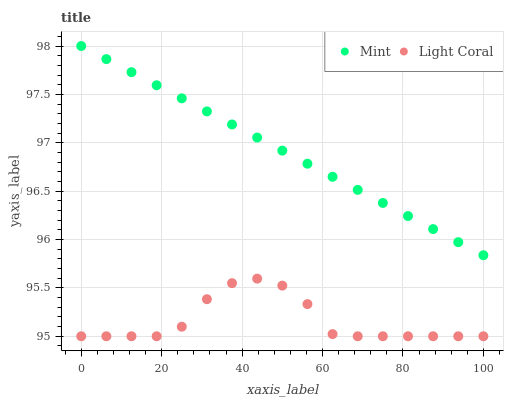Does Light Coral have the minimum area under the curve?
Answer yes or no. Yes. Does Mint have the maximum area under the curve?
Answer yes or no. Yes. Does Mint have the minimum area under the curve?
Answer yes or no. No. Is Mint the smoothest?
Answer yes or no. Yes. Is Light Coral the roughest?
Answer yes or no. Yes. Is Mint the roughest?
Answer yes or no. No. Does Light Coral have the lowest value?
Answer yes or no. Yes. Does Mint have the lowest value?
Answer yes or no. No. Does Mint have the highest value?
Answer yes or no. Yes. Is Light Coral less than Mint?
Answer yes or no. Yes. Is Mint greater than Light Coral?
Answer yes or no. Yes. Does Light Coral intersect Mint?
Answer yes or no. No. 